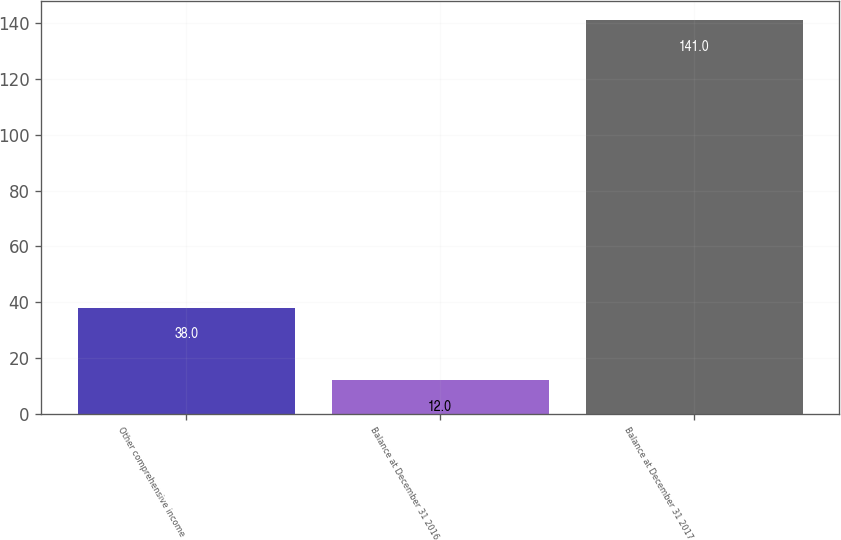Convert chart. <chart><loc_0><loc_0><loc_500><loc_500><bar_chart><fcel>Other comprehensive income<fcel>Balance at December 31 2016<fcel>Balance at December 31 2017<nl><fcel>38<fcel>12<fcel>141<nl></chart> 